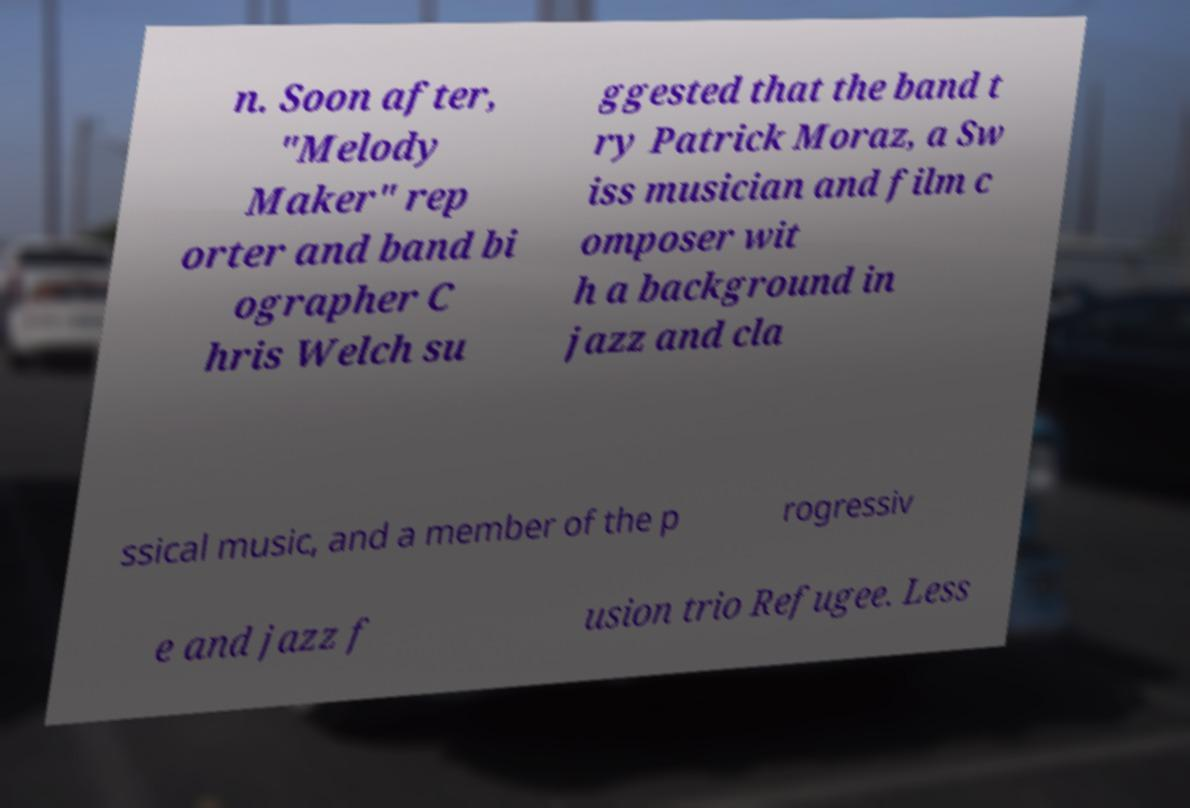Can you read and provide the text displayed in the image?This photo seems to have some interesting text. Can you extract and type it out for me? n. Soon after, "Melody Maker" rep orter and band bi ographer C hris Welch su ggested that the band t ry Patrick Moraz, a Sw iss musician and film c omposer wit h a background in jazz and cla ssical music, and a member of the p rogressiv e and jazz f usion trio Refugee. Less 